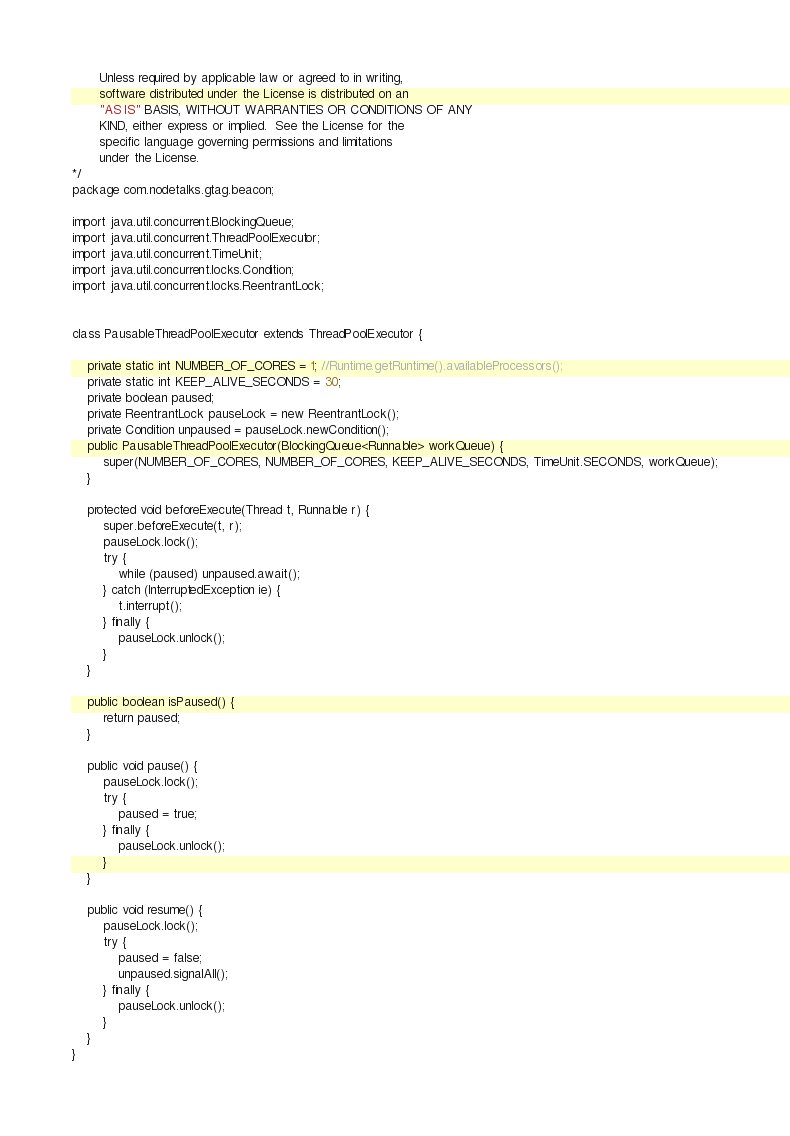Convert code to text. <code><loc_0><loc_0><loc_500><loc_500><_Java_>       Unless required by applicable law or agreed to in writing,
       software distributed under the License is distributed on an
       "AS IS" BASIS, WITHOUT WARRANTIES OR CONDITIONS OF ANY
       KIND, either express or implied.  See the License for the
       specific language governing permissions and limitations
       under the License.
*/
package com.nodetalks.gtag.beacon;

import java.util.concurrent.BlockingQueue;
import java.util.concurrent.ThreadPoolExecutor;
import java.util.concurrent.TimeUnit;
import java.util.concurrent.locks.Condition;
import java.util.concurrent.locks.ReentrantLock;


class PausableThreadPoolExecutor extends ThreadPoolExecutor {

    private static int NUMBER_OF_CORES = 1; //Runtime.getRuntime().availableProcessors();
    private static int KEEP_ALIVE_SECONDS = 30;
    private boolean paused;
    private ReentrantLock pauseLock = new ReentrantLock();
    private Condition unpaused = pauseLock.newCondition();
    public PausableThreadPoolExecutor(BlockingQueue<Runnable> workQueue) {
        super(NUMBER_OF_CORES, NUMBER_OF_CORES, KEEP_ALIVE_SECONDS, TimeUnit.SECONDS, workQueue);
    }

    protected void beforeExecute(Thread t, Runnable r) {
        super.beforeExecute(t, r);
        pauseLock.lock();
        try {
            while (paused) unpaused.await();
        } catch (InterruptedException ie) {
            t.interrupt();
        } finally {
            pauseLock.unlock();
        }
    }

    public boolean isPaused() {
        return paused;
    }

    public void pause() {
        pauseLock.lock();
        try {
            paused = true;
        } finally {
            pauseLock.unlock();
        }
    }

    public void resume() {
        pauseLock.lock();
        try {
            paused = false;
            unpaused.signalAll();
        } finally {
            pauseLock.unlock();
        }
    }
}</code> 